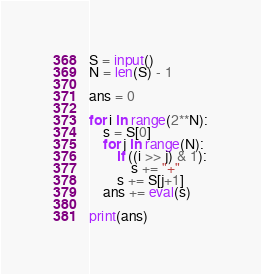Convert code to text. <code><loc_0><loc_0><loc_500><loc_500><_Python_>S = input()
N = len(S) - 1

ans = 0

for i in range(2**N):
    s = S[0]
    for j in range(N):
        if ((i >> j) & 1):
            s += "+"
        s += S[j+1]
    ans += eval(s)

print(ans)</code> 